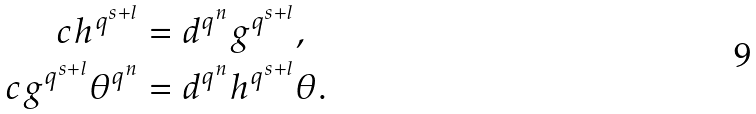Convert formula to latex. <formula><loc_0><loc_0><loc_500><loc_500>c h ^ { q ^ { s + l } } & = d ^ { q ^ { n } } g ^ { q ^ { s + l } } , \\ c g ^ { q ^ { s + l } } \theta ^ { q ^ { n } } & = d ^ { q ^ { n } } h ^ { q ^ { s + l } } \theta .</formula> 